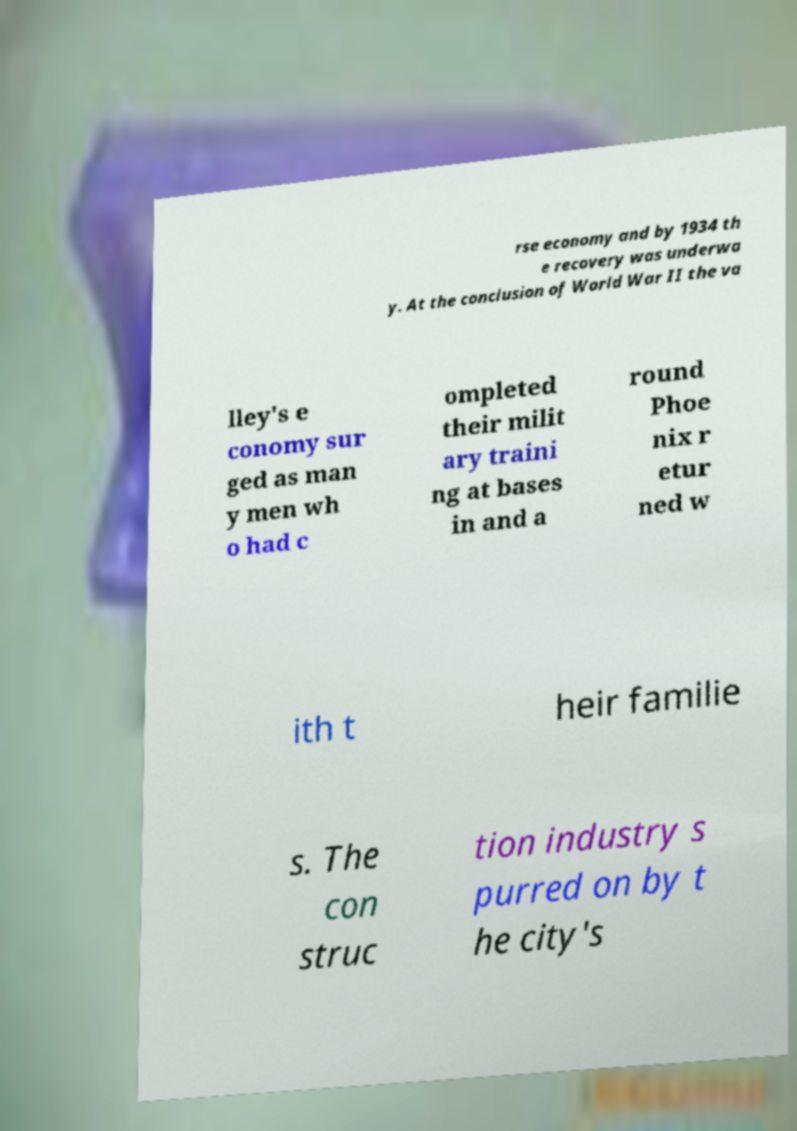I need the written content from this picture converted into text. Can you do that? rse economy and by 1934 th e recovery was underwa y. At the conclusion of World War II the va lley's e conomy sur ged as man y men wh o had c ompleted their milit ary traini ng at bases in and a round Phoe nix r etur ned w ith t heir familie s. The con struc tion industry s purred on by t he city's 